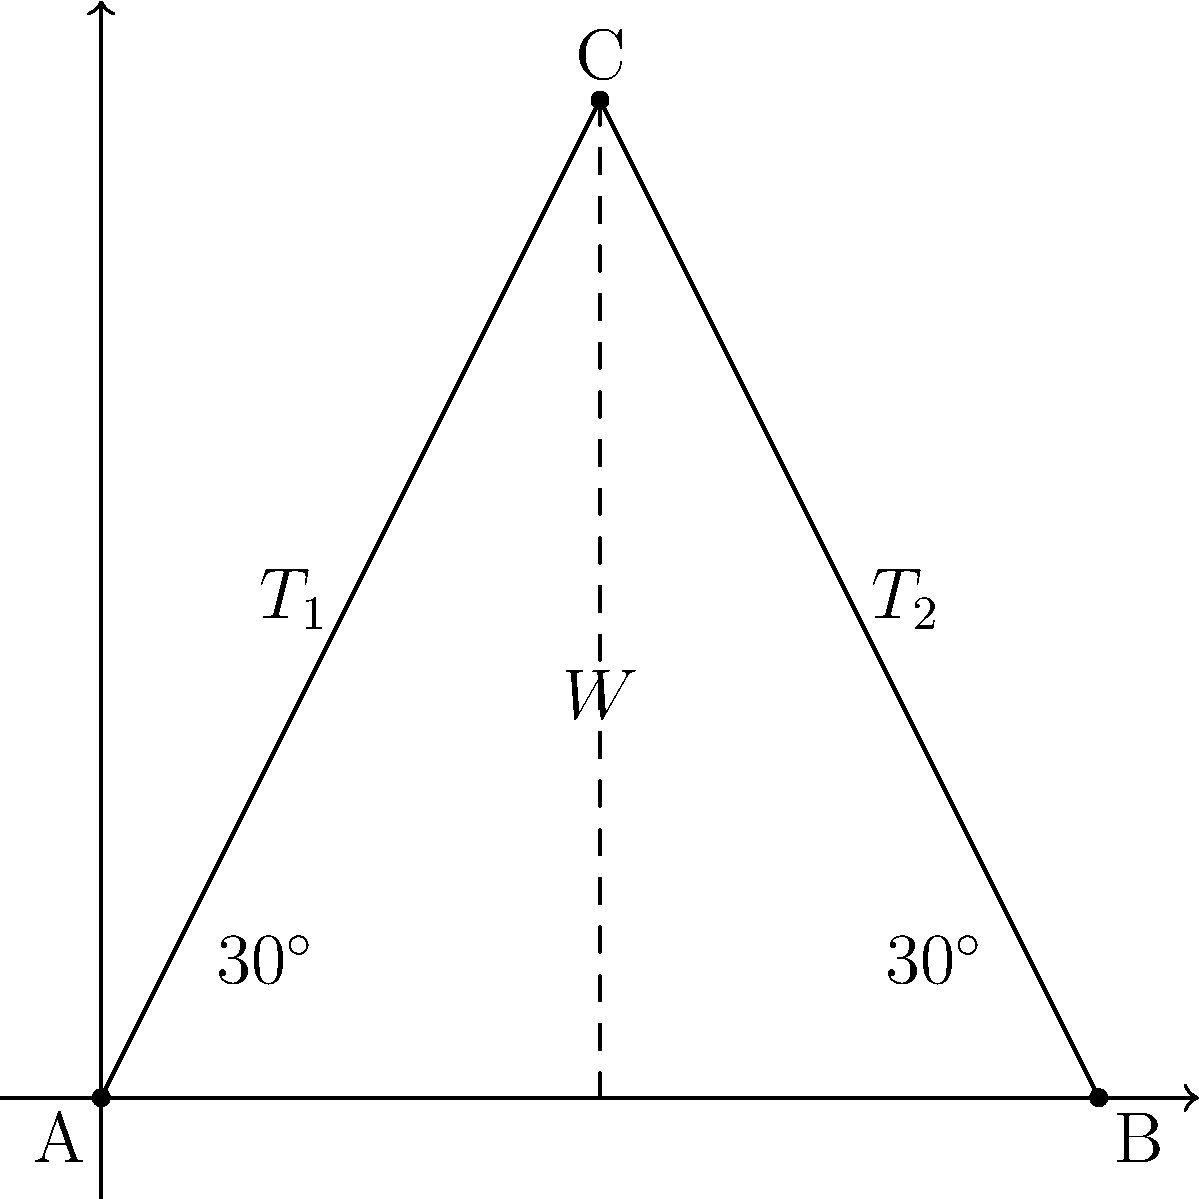In a new theatrical production, a heavy spotlight weighing 500 N needs to be suspended above the stage. The lighting designer decides to use two cables attached to the ceiling, forming a symmetrical arrangement as shown in the diagram. If each cable makes a 30° angle with the horizontal, calculate the tension in each cable required to keep the spotlight in equilibrium. To solve this problem, we'll follow these steps:

1) First, we need to understand that the system is in equilibrium, so the sum of all forces must be zero.

2) We can break this problem into vertical and horizontal components:
   - Vertical: The upward force from the cables must balance the weight of the spotlight.
   - Horizontal: The horizontal components of the cable tensions must cancel each other out due to symmetry.

3) Let's focus on one cable. The tension $T$ in the cable can be broken into vertical and horizontal components:
   - Vertical component: $T_v = T \sin 30°$
   - Horizontal component: $T_h = T \cos 30°$

4) The total vertical force from both cables must equal the weight of the spotlight:
   $2T_v = W$
   $2T \sin 30° = 500 \text{ N}$

5) We know that $\sin 30° = \frac{1}{2}$, so:
   $2T \cdot \frac{1}{2} = 500 \text{ N}$
   $T = 500 \text{ N}$

6) Therefore, the tension in each cable is 500 N.

7) We can verify this by checking the horizontal components:
   $T_h = 500 \cos 30° = 500 \cdot \frac{\sqrt{3}}{2} = 433 \text{ N}$
   The horizontal components are equal and opposite, confirming equilibrium.
Answer: 500 N 